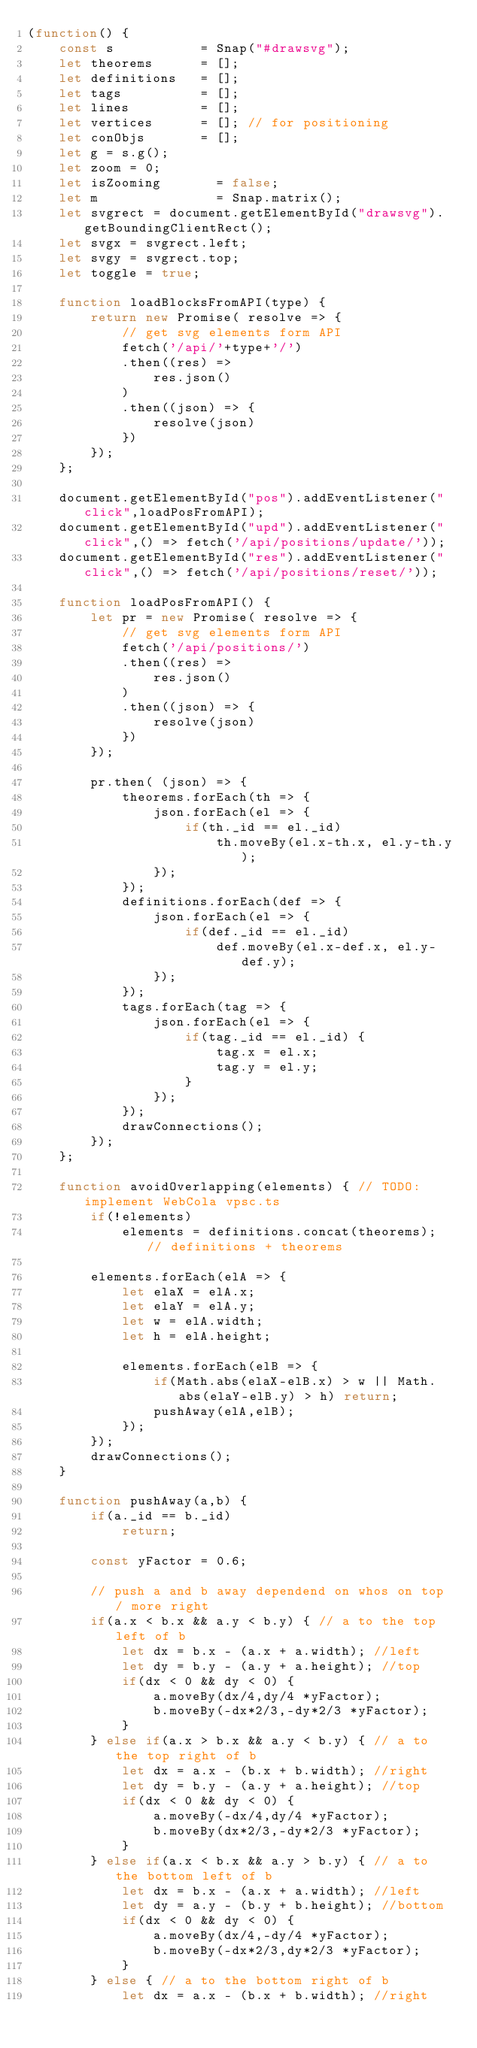Convert code to text. <code><loc_0><loc_0><loc_500><loc_500><_JavaScript_>(function() {
    const s           = Snap("#drawsvg");
    let theorems      = [];
    let definitions   = [];
    let tags          = [];
    let lines         = [];
    let vertices      = []; // for positioning
    let conObjs       = [];
    let g = s.g();
    let zoom = 0;
    let isZooming       = false;
    let m               = Snap.matrix();
    let svgrect = document.getElementById("drawsvg").getBoundingClientRect();
    let svgx = svgrect.left;
    let svgy = svgrect.top;
    let toggle = true;

    function loadBlocksFromAPI(type) {
        return new Promise( resolve => {
            // get svg elements form API
            fetch('/api/'+type+'/')
            .then((res) => 
                res.json()
            )
            .then((json) => {
                resolve(json)
            })
        }); 
    };

    document.getElementById("pos").addEventListener("click",loadPosFromAPI);
    document.getElementById("upd").addEventListener("click",() => fetch('/api/positions/update/'));
    document.getElementById("res").addEventListener("click",() => fetch('/api/positions/reset/'));

    function loadPosFromAPI() {
        let pr = new Promise( resolve => {
            // get svg elements form API
            fetch('/api/positions/')
            .then((res) => 
                res.json()
            )
            .then((json) => {
                resolve(json)
            })
        });

        pr.then( (json) => {
            theorems.forEach(th => {
                json.forEach(el => {
                    if(th._id == el._id)
                        th.moveBy(el.x-th.x, el.y-th.y);
                });
            });
            definitions.forEach(def => {
                json.forEach(el => {
                    if(def._id == el._id)
                        def.moveBy(el.x-def.x, el.y-def.y);
                });
            });
            tags.forEach(tag => {
                json.forEach(el => {
                    if(tag._id == el._id) {
                        tag.x = el.x;
                        tag.y = el.y;
                    }
                });
            });
            drawConnections();
        });
    };

    function avoidOverlapping(elements) { // TODO: implement WebCola vpsc.ts 
        if(!elements)
            elements = definitions.concat(theorems); // definitions + theorems  

        elements.forEach(elA => {
            let elaX = elA.x;
            let elaY = elA.y;
            let w = elA.width;
            let h = elA.height;

            elements.forEach(elB => {
                if(Math.abs(elaX-elB.x) > w || Math.abs(elaY-elB.y) > h) return;
                pushAway(elA,elB);
            });
        });
        drawConnections();
    }

    function pushAway(a,b) {
        if(a._id == b._id)
            return;

        const yFactor = 0.6;
        
        // push a and b away dependend on whos on top / more right
        if(a.x < b.x && a.y < b.y) { // a to the top left of b
            let dx = b.x - (a.x + a.width); //left
            let dy = b.y - (a.y + a.height); //top
            if(dx < 0 && dy < 0) {
                a.moveBy(dx/4,dy/4 *yFactor);
                b.moveBy(-dx*2/3,-dy*2/3 *yFactor);
            }
        } else if(a.x > b.x && a.y < b.y) { // a to the top right of b
            let dx = a.x - (b.x + b.width); //right
            let dy = b.y - (a.y + a.height); //top
            if(dx < 0 && dy < 0) {
                a.moveBy(-dx/4,dy/4 *yFactor);
                b.moveBy(dx*2/3,-dy*2/3 *yFactor);
            }
        } else if(a.x < b.x && a.y > b.y) { // a to the bottom left of b
            let dx = b.x - (a.x + a.width); //left
            let dy = a.y - (b.y + b.height); //bottom
            if(dx < 0 && dy < 0) {
                a.moveBy(dx/4,-dy/4 *yFactor);
                b.moveBy(-dx*2/3,dy*2/3 *yFactor);
            }
        } else { // a to the bottom right of b
            let dx = a.x - (b.x + b.width); //right</code> 